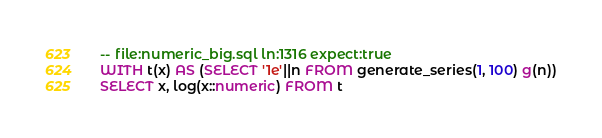Convert code to text. <code><loc_0><loc_0><loc_500><loc_500><_SQL_>-- file:numeric_big.sql ln:1316 expect:true
WITH t(x) AS (SELECT '1e'||n FROM generate_series(1, 100) g(n))
SELECT x, log(x::numeric) FROM t
</code> 